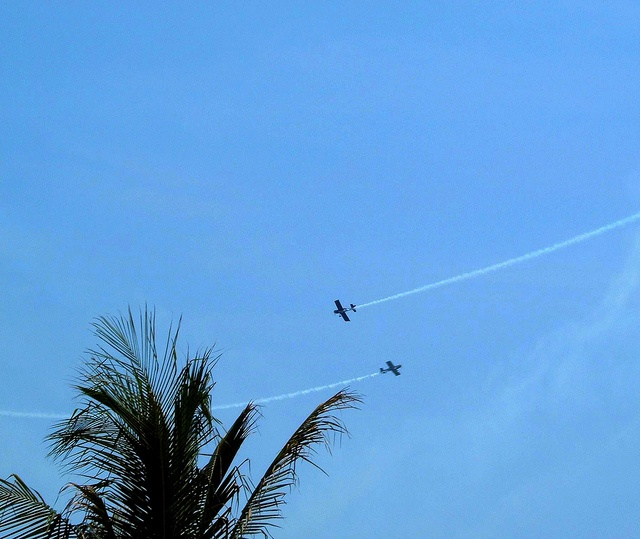Describe the objects in this image and their specific colors. I can see airplane in lightblue, navy, blue, and gray tones and airplane in lightblue, darkblue, blue, and darkgray tones in this image. 